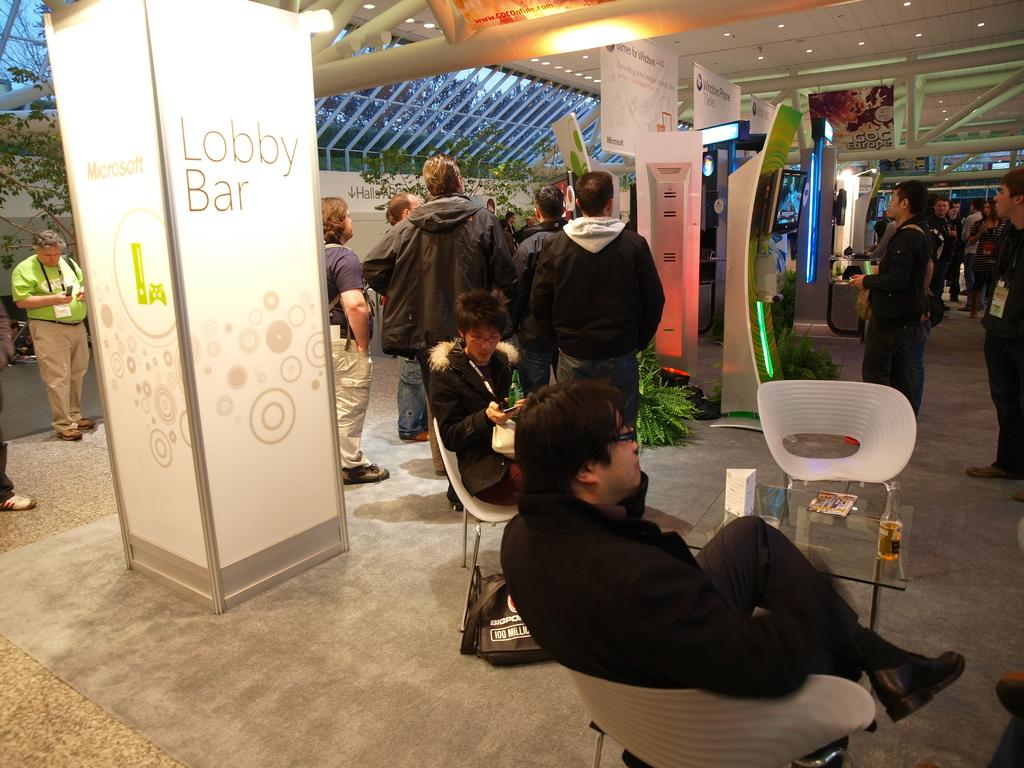What is happening inside the building in the image? There are people inside the building in the image. Can you describe the position of some of the people? Some people are sitting on chairs. What type of decorations or signs can be seen in the image? There are banners visible in the image. What type of natural elements are present in the image? There are trees in the image. What type of linen is draped over the chairs in the image? There is no linen draped over the chairs in the image; the chairs are visible without any fabric covering them. 